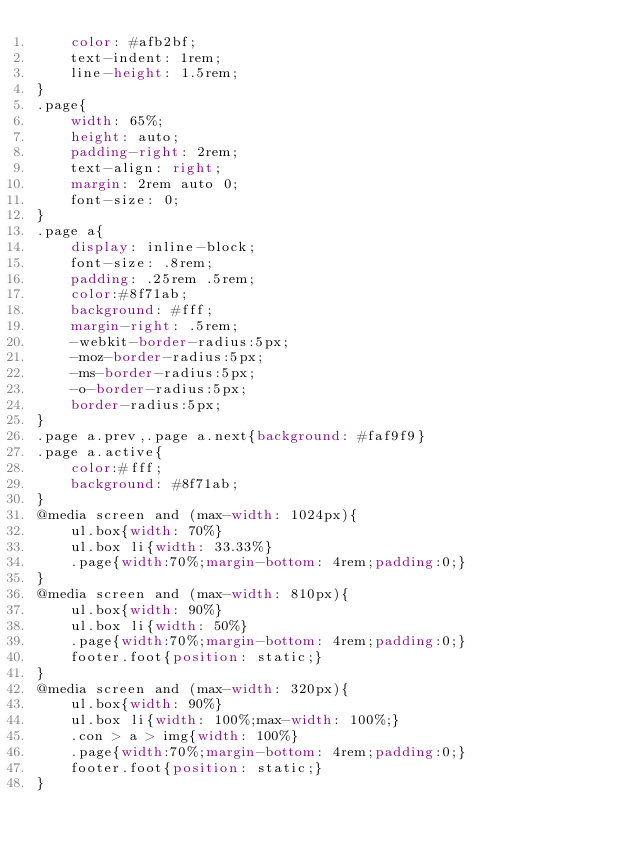Convert code to text. <code><loc_0><loc_0><loc_500><loc_500><_CSS_>	color: #afb2bf;
	text-indent: 1rem;
	line-height: 1.5rem;
}
.page{
	width: 65%;
	height: auto;
	padding-right: 2rem;
	text-align: right;
	margin: 2rem auto 0;
	font-size: 0;
}
.page a{
	display: inline-block;
	font-size: .8rem;
	padding: .25rem .5rem;
	color:#8f71ab;
	background: #fff;
	margin-right: .5rem;
	-webkit-border-radius:5px;
	-moz-border-radius:5px;
	-ms-border-radius:5px;
	-o-border-radius:5px;
	border-radius:5px;
}
.page a.prev,.page a.next{background: #faf9f9}
.page a.active{
	color:#fff;
	background: #8f71ab;
}
@media screen and (max-width: 1024px){
	ul.box{width: 70%}
	ul.box li{width: 33.33%}
	.page{width:70%;margin-bottom: 4rem;padding:0;}
}
@media screen and (max-width: 810px){
	ul.box{width: 90%}
	ul.box li{width: 50%}
	.page{width:70%;margin-bottom: 4rem;padding:0;}
	footer.foot{position: static;}
}
@media screen and (max-width: 320px){
	ul.box{width: 90%}
	ul.box li{width: 100%;max-width: 100%;}
	.con > a > img{width: 100%}
	.page{width:70%;margin-bottom: 4rem;padding:0;}
	footer.foot{position: static;}
}</code> 